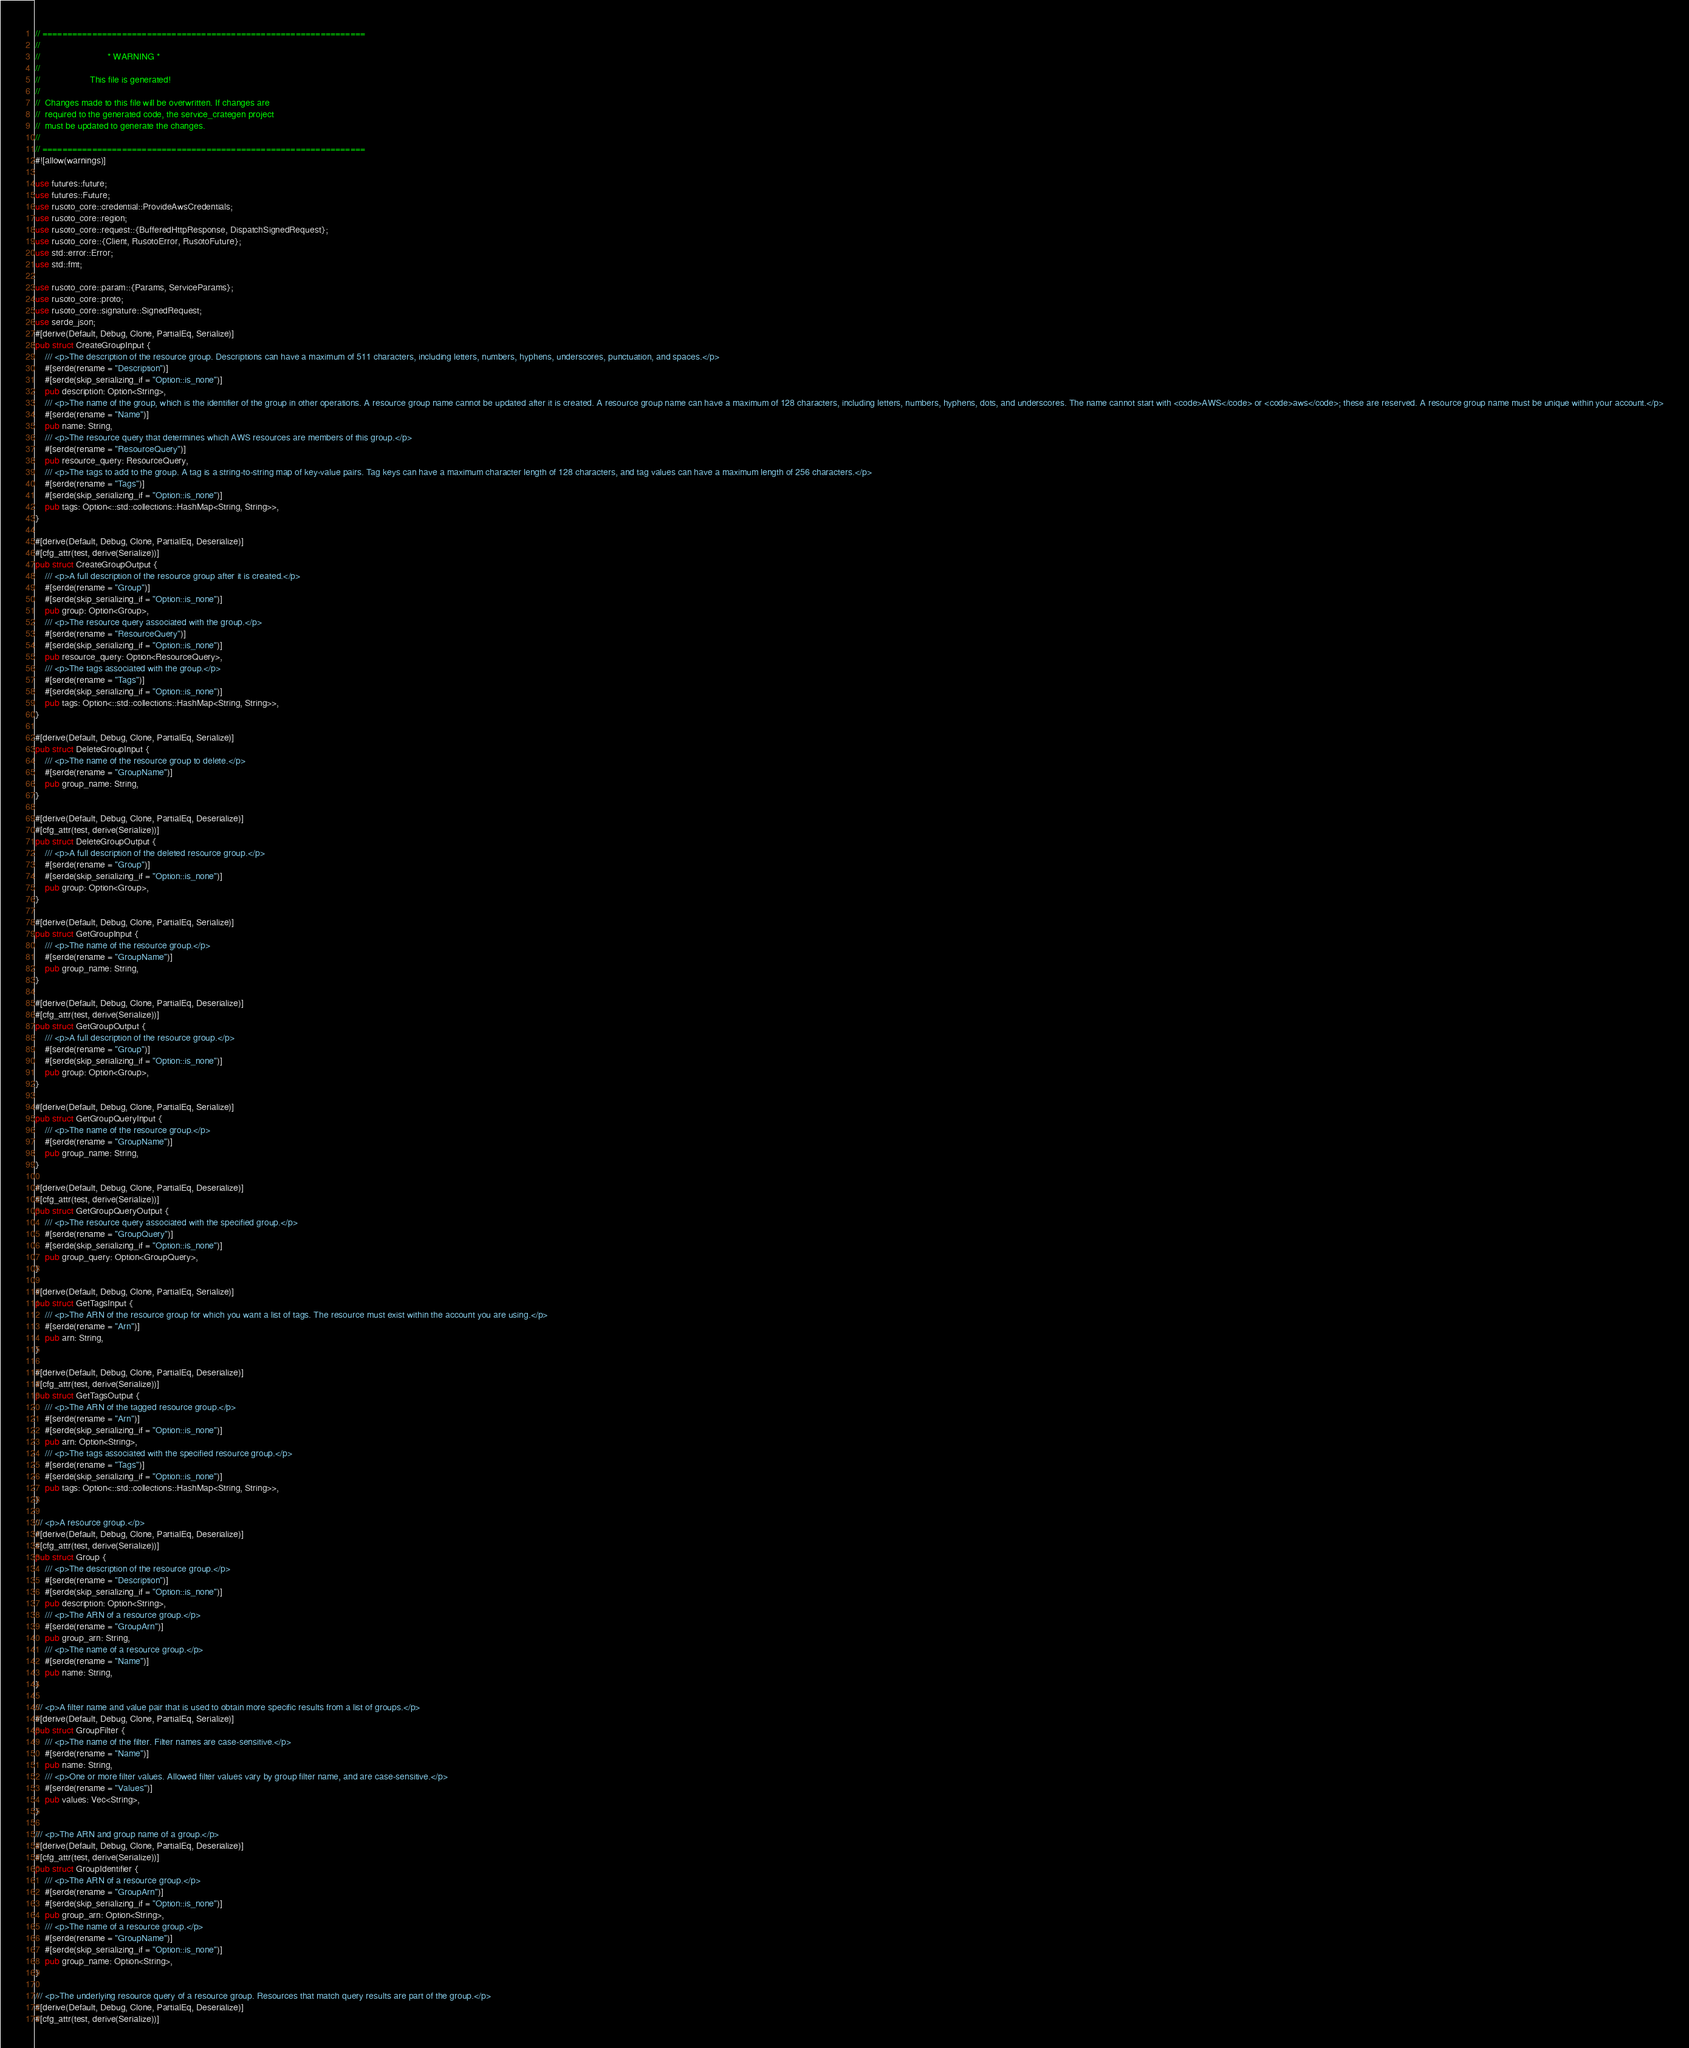Convert code to text. <code><loc_0><loc_0><loc_500><loc_500><_Rust_>// =================================================================
//
//                           * WARNING *
//
//                    This file is generated!
//
//  Changes made to this file will be overwritten. If changes are
//  required to the generated code, the service_crategen project
//  must be updated to generate the changes.
//
// =================================================================
#![allow(warnings)]

use futures::future;
use futures::Future;
use rusoto_core::credential::ProvideAwsCredentials;
use rusoto_core::region;
use rusoto_core::request::{BufferedHttpResponse, DispatchSignedRequest};
use rusoto_core::{Client, RusotoError, RusotoFuture};
use std::error::Error;
use std::fmt;

use rusoto_core::param::{Params, ServiceParams};
use rusoto_core::proto;
use rusoto_core::signature::SignedRequest;
use serde_json;
#[derive(Default, Debug, Clone, PartialEq, Serialize)]
pub struct CreateGroupInput {
    /// <p>The description of the resource group. Descriptions can have a maximum of 511 characters, including letters, numbers, hyphens, underscores, punctuation, and spaces.</p>
    #[serde(rename = "Description")]
    #[serde(skip_serializing_if = "Option::is_none")]
    pub description: Option<String>,
    /// <p>The name of the group, which is the identifier of the group in other operations. A resource group name cannot be updated after it is created. A resource group name can have a maximum of 128 characters, including letters, numbers, hyphens, dots, and underscores. The name cannot start with <code>AWS</code> or <code>aws</code>; these are reserved. A resource group name must be unique within your account.</p>
    #[serde(rename = "Name")]
    pub name: String,
    /// <p>The resource query that determines which AWS resources are members of this group.</p>
    #[serde(rename = "ResourceQuery")]
    pub resource_query: ResourceQuery,
    /// <p>The tags to add to the group. A tag is a string-to-string map of key-value pairs. Tag keys can have a maximum character length of 128 characters, and tag values can have a maximum length of 256 characters.</p>
    #[serde(rename = "Tags")]
    #[serde(skip_serializing_if = "Option::is_none")]
    pub tags: Option<::std::collections::HashMap<String, String>>,
}

#[derive(Default, Debug, Clone, PartialEq, Deserialize)]
#[cfg_attr(test, derive(Serialize))]
pub struct CreateGroupOutput {
    /// <p>A full description of the resource group after it is created.</p>
    #[serde(rename = "Group")]
    #[serde(skip_serializing_if = "Option::is_none")]
    pub group: Option<Group>,
    /// <p>The resource query associated with the group.</p>
    #[serde(rename = "ResourceQuery")]
    #[serde(skip_serializing_if = "Option::is_none")]
    pub resource_query: Option<ResourceQuery>,
    /// <p>The tags associated with the group.</p>
    #[serde(rename = "Tags")]
    #[serde(skip_serializing_if = "Option::is_none")]
    pub tags: Option<::std::collections::HashMap<String, String>>,
}

#[derive(Default, Debug, Clone, PartialEq, Serialize)]
pub struct DeleteGroupInput {
    /// <p>The name of the resource group to delete.</p>
    #[serde(rename = "GroupName")]
    pub group_name: String,
}

#[derive(Default, Debug, Clone, PartialEq, Deserialize)]
#[cfg_attr(test, derive(Serialize))]
pub struct DeleteGroupOutput {
    /// <p>A full description of the deleted resource group.</p>
    #[serde(rename = "Group")]
    #[serde(skip_serializing_if = "Option::is_none")]
    pub group: Option<Group>,
}

#[derive(Default, Debug, Clone, PartialEq, Serialize)]
pub struct GetGroupInput {
    /// <p>The name of the resource group.</p>
    #[serde(rename = "GroupName")]
    pub group_name: String,
}

#[derive(Default, Debug, Clone, PartialEq, Deserialize)]
#[cfg_attr(test, derive(Serialize))]
pub struct GetGroupOutput {
    /// <p>A full description of the resource group.</p>
    #[serde(rename = "Group")]
    #[serde(skip_serializing_if = "Option::is_none")]
    pub group: Option<Group>,
}

#[derive(Default, Debug, Clone, PartialEq, Serialize)]
pub struct GetGroupQueryInput {
    /// <p>The name of the resource group.</p>
    #[serde(rename = "GroupName")]
    pub group_name: String,
}

#[derive(Default, Debug, Clone, PartialEq, Deserialize)]
#[cfg_attr(test, derive(Serialize))]
pub struct GetGroupQueryOutput {
    /// <p>The resource query associated with the specified group.</p>
    #[serde(rename = "GroupQuery")]
    #[serde(skip_serializing_if = "Option::is_none")]
    pub group_query: Option<GroupQuery>,
}

#[derive(Default, Debug, Clone, PartialEq, Serialize)]
pub struct GetTagsInput {
    /// <p>The ARN of the resource group for which you want a list of tags. The resource must exist within the account you are using.</p>
    #[serde(rename = "Arn")]
    pub arn: String,
}

#[derive(Default, Debug, Clone, PartialEq, Deserialize)]
#[cfg_attr(test, derive(Serialize))]
pub struct GetTagsOutput {
    /// <p>The ARN of the tagged resource group.</p>
    #[serde(rename = "Arn")]
    #[serde(skip_serializing_if = "Option::is_none")]
    pub arn: Option<String>,
    /// <p>The tags associated with the specified resource group.</p>
    #[serde(rename = "Tags")]
    #[serde(skip_serializing_if = "Option::is_none")]
    pub tags: Option<::std::collections::HashMap<String, String>>,
}

/// <p>A resource group.</p>
#[derive(Default, Debug, Clone, PartialEq, Deserialize)]
#[cfg_attr(test, derive(Serialize))]
pub struct Group {
    /// <p>The description of the resource group.</p>
    #[serde(rename = "Description")]
    #[serde(skip_serializing_if = "Option::is_none")]
    pub description: Option<String>,
    /// <p>The ARN of a resource group.</p>
    #[serde(rename = "GroupArn")]
    pub group_arn: String,
    /// <p>The name of a resource group.</p>
    #[serde(rename = "Name")]
    pub name: String,
}

/// <p>A filter name and value pair that is used to obtain more specific results from a list of groups.</p>
#[derive(Default, Debug, Clone, PartialEq, Serialize)]
pub struct GroupFilter {
    /// <p>The name of the filter. Filter names are case-sensitive.</p>
    #[serde(rename = "Name")]
    pub name: String,
    /// <p>One or more filter values. Allowed filter values vary by group filter name, and are case-sensitive.</p>
    #[serde(rename = "Values")]
    pub values: Vec<String>,
}

/// <p>The ARN and group name of a group.</p>
#[derive(Default, Debug, Clone, PartialEq, Deserialize)]
#[cfg_attr(test, derive(Serialize))]
pub struct GroupIdentifier {
    /// <p>The ARN of a resource group.</p>
    #[serde(rename = "GroupArn")]
    #[serde(skip_serializing_if = "Option::is_none")]
    pub group_arn: Option<String>,
    /// <p>The name of a resource group.</p>
    #[serde(rename = "GroupName")]
    #[serde(skip_serializing_if = "Option::is_none")]
    pub group_name: Option<String>,
}

/// <p>The underlying resource query of a resource group. Resources that match query results are part of the group.</p>
#[derive(Default, Debug, Clone, PartialEq, Deserialize)]
#[cfg_attr(test, derive(Serialize))]</code> 